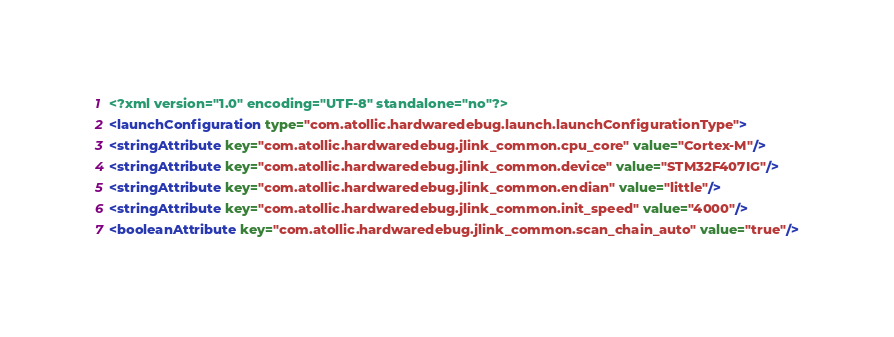<code> <loc_0><loc_0><loc_500><loc_500><_XML_><?xml version="1.0" encoding="UTF-8" standalone="no"?>
<launchConfiguration type="com.atollic.hardwaredebug.launch.launchConfigurationType">
<stringAttribute key="com.atollic.hardwaredebug.jlink_common.cpu_core" value="Cortex-M"/>
<stringAttribute key="com.atollic.hardwaredebug.jlink_common.device" value="STM32F407IG"/>
<stringAttribute key="com.atollic.hardwaredebug.jlink_common.endian" value="little"/>
<stringAttribute key="com.atollic.hardwaredebug.jlink_common.init_speed" value="4000"/>
<booleanAttribute key="com.atollic.hardwaredebug.jlink_common.scan_chain_auto" value="true"/></code> 